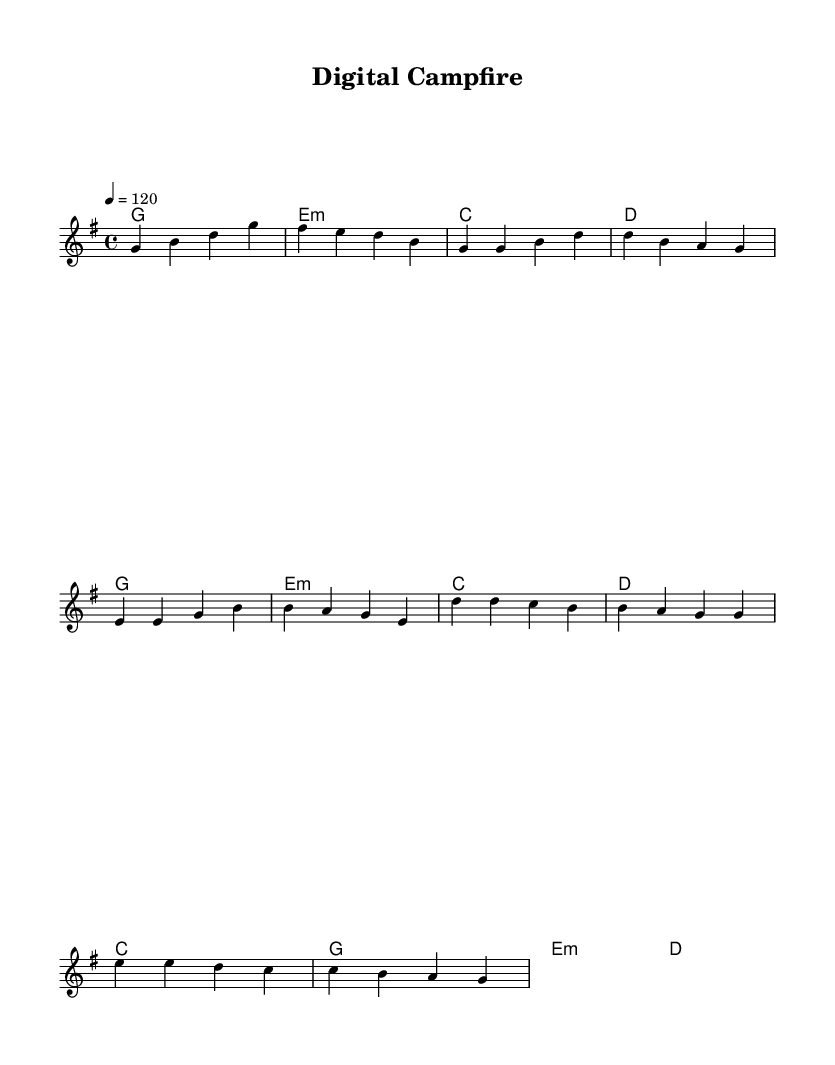What is the key signature of this music? The key signature is G major, indicated by the one sharp (F#) seen at the beginning of the staff.
Answer: G major What is the time signature of this music? The time signature is 4/4, shown at the beginning of the score as a fraction with 4 beats in a measure and a quarter note as the beat unit.
Answer: 4/4 What is the tempo marking for this piece? The tempo marking indicates a tempo of 120 beats per minute, specified in the score near the beginning, stating "4 = 120".
Answer: 120 How many measures are there in the melody section? Counting the measures in the provided melody section, there are 10 measures total: 2 for the introduction, 4 for the verse, and 4 for the chorus.
Answer: 10 What chord follows the introduction? The introduction chords are g, e minor, c, and d, and the first chord following the introduction is g major at the start of the verse.
Answer: g Which section has a different chord compared to the rest? The chorus section features an e minor chord that is distinct from the introductory and verse sections where the e minor chord appears less prominently.
Answer: chorus 